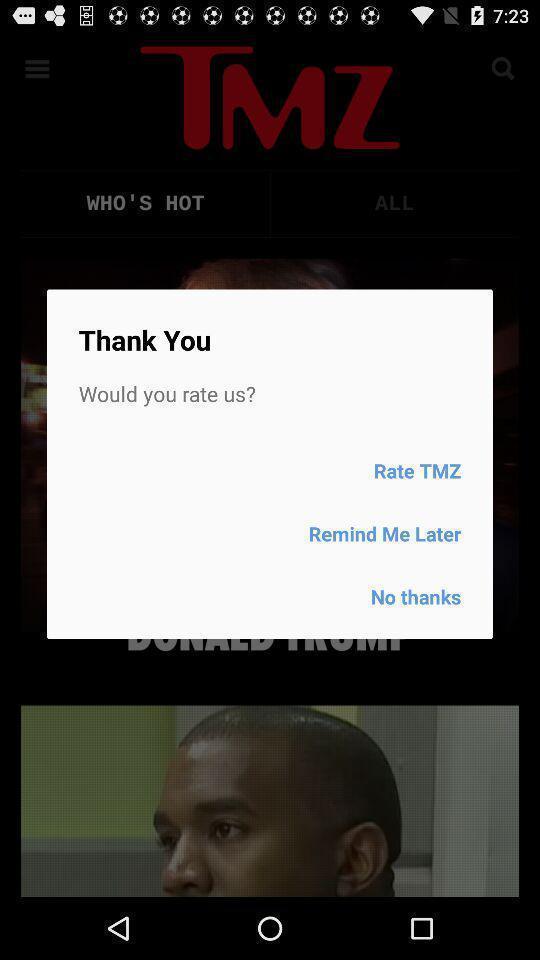Provide a description of this screenshot. Pop-up to rate an app. 